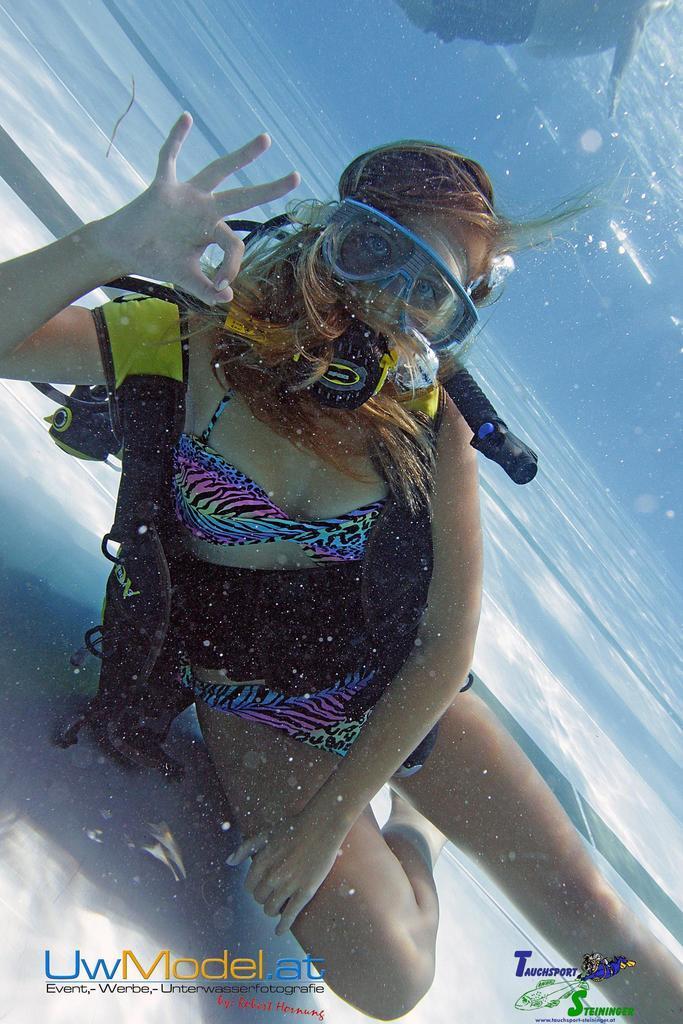Describe this image in one or two sentences. In this picture there is a girl in the center of the image in the water, she is swimming. 